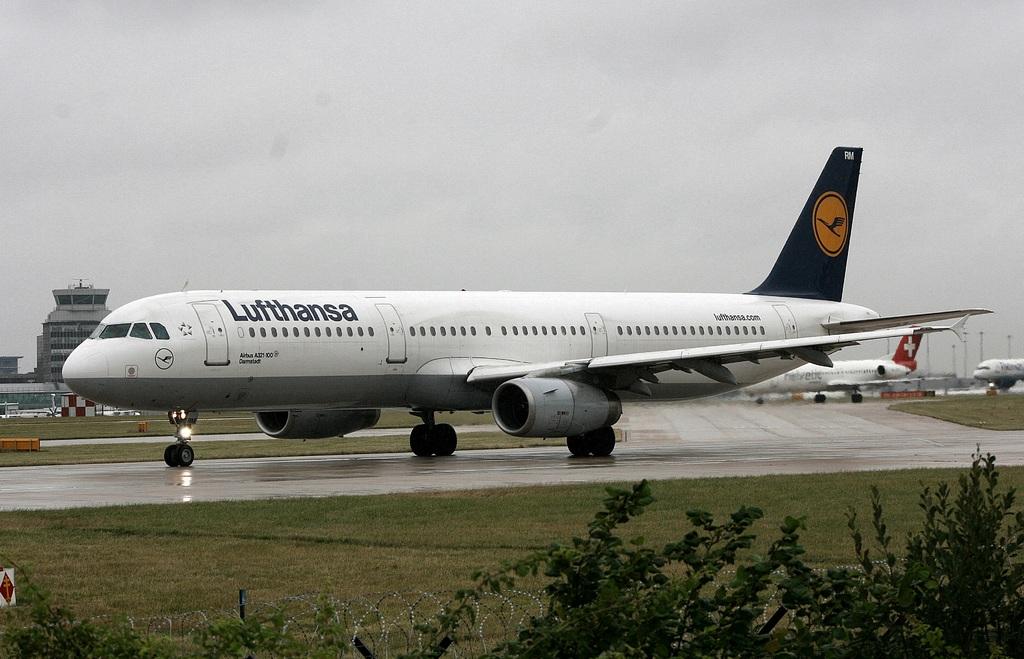What is the plane brand?
Provide a short and direct response. Lufthansa. 